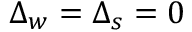<formula> <loc_0><loc_0><loc_500><loc_500>\Delta _ { w } = \Delta _ { s } = 0</formula> 